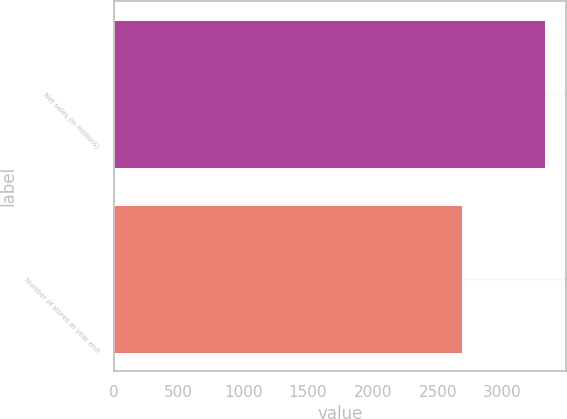<chart> <loc_0><loc_0><loc_500><loc_500><bar_chart><fcel>Net sales (in millions)<fcel>Number of stores at year end<nl><fcel>3326.1<fcel>2687<nl></chart> 